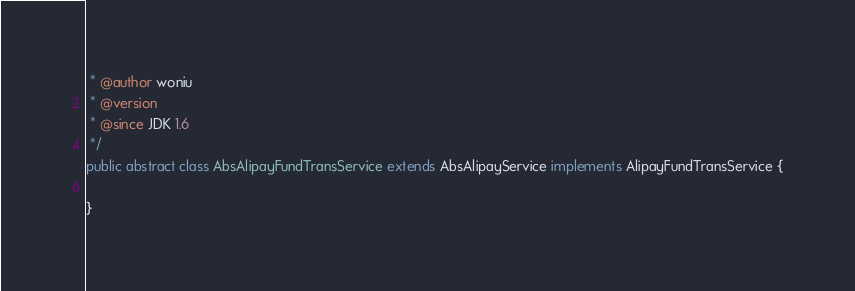Convert code to text. <code><loc_0><loc_0><loc_500><loc_500><_Java_> * @author woniu 
 * @version  
 * @since JDK 1.6 
 */
public abstract class AbsAlipayFundTransService extends AbsAlipayService implements AlipayFundTransService {

}
</code> 